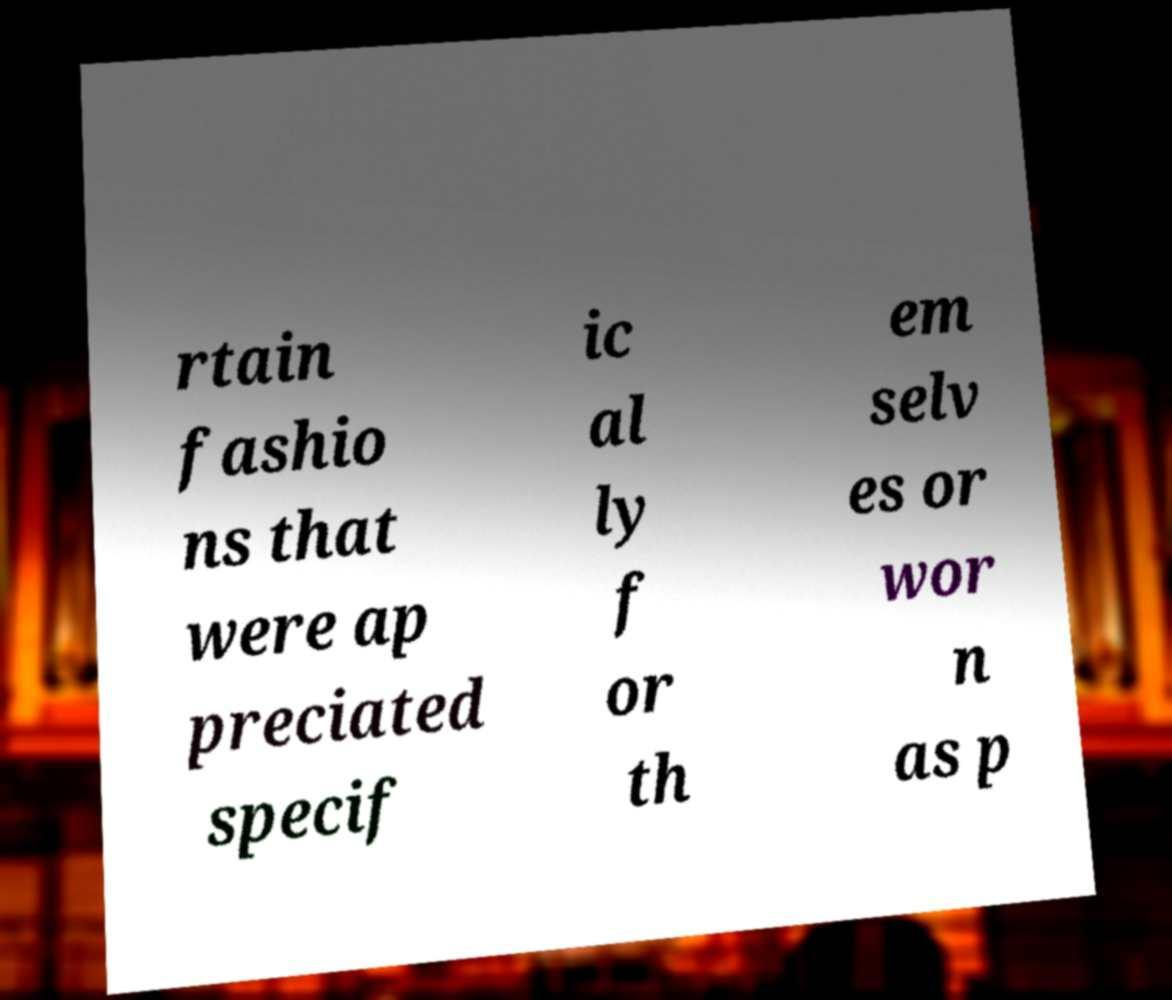For documentation purposes, I need the text within this image transcribed. Could you provide that? rtain fashio ns that were ap preciated specif ic al ly f or th em selv es or wor n as p 